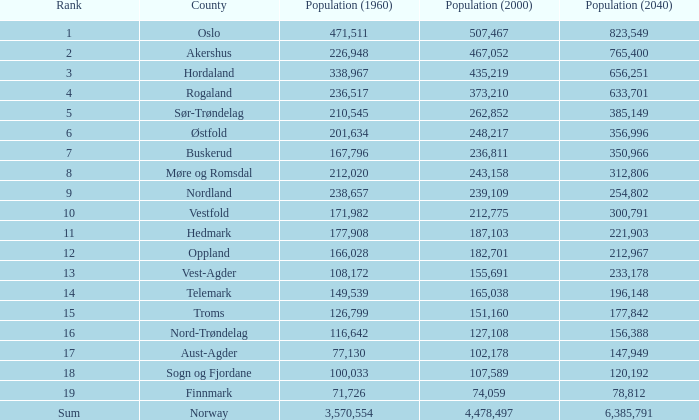I'm looking to parse the entire table for insights. Could you assist me with that? {'header': ['Rank', 'County', 'Population (1960)', 'Population (2000)', 'Population (2040)'], 'rows': [['1', 'Oslo', '471,511', '507,467', '823,549'], ['2', 'Akershus', '226,948', '467,052', '765,400'], ['3', 'Hordaland', '338,967', '435,219', '656,251'], ['4', 'Rogaland', '236,517', '373,210', '633,701'], ['5', 'Sør-Trøndelag', '210,545', '262,852', '385,149'], ['6', 'Østfold', '201,634', '248,217', '356,996'], ['7', 'Buskerud', '167,796', '236,811', '350,966'], ['8', 'Møre og Romsdal', '212,020', '243,158', '312,806'], ['9', 'Nordland', '238,657', '239,109', '254,802'], ['10', 'Vestfold', '171,982', '212,775', '300,791'], ['11', 'Hedmark', '177,908', '187,103', '221,903'], ['12', 'Oppland', '166,028', '182,701', '212,967'], ['13', 'Vest-Agder', '108,172', '155,691', '233,178'], ['14', 'Telemark', '149,539', '165,038', '196,148'], ['15', 'Troms', '126,799', '151,160', '177,842'], ['16', 'Nord-Trøndelag', '116,642', '127,108', '156,388'], ['17', 'Aust-Agder', '77,130', '102,178', '147,949'], ['18', 'Sogn og Fjordane', '100,033', '107,589', '120,192'], ['19', 'Finnmark', '71,726', '74,059', '78,812'], ['Sum', 'Norway', '3,570,554', '4,478,497', '6,385,791']]} What was the number of inhabitants in a county in 2040 that had a population below 108,172 in 2000 and under 107,589 in 1960? 2.0. 